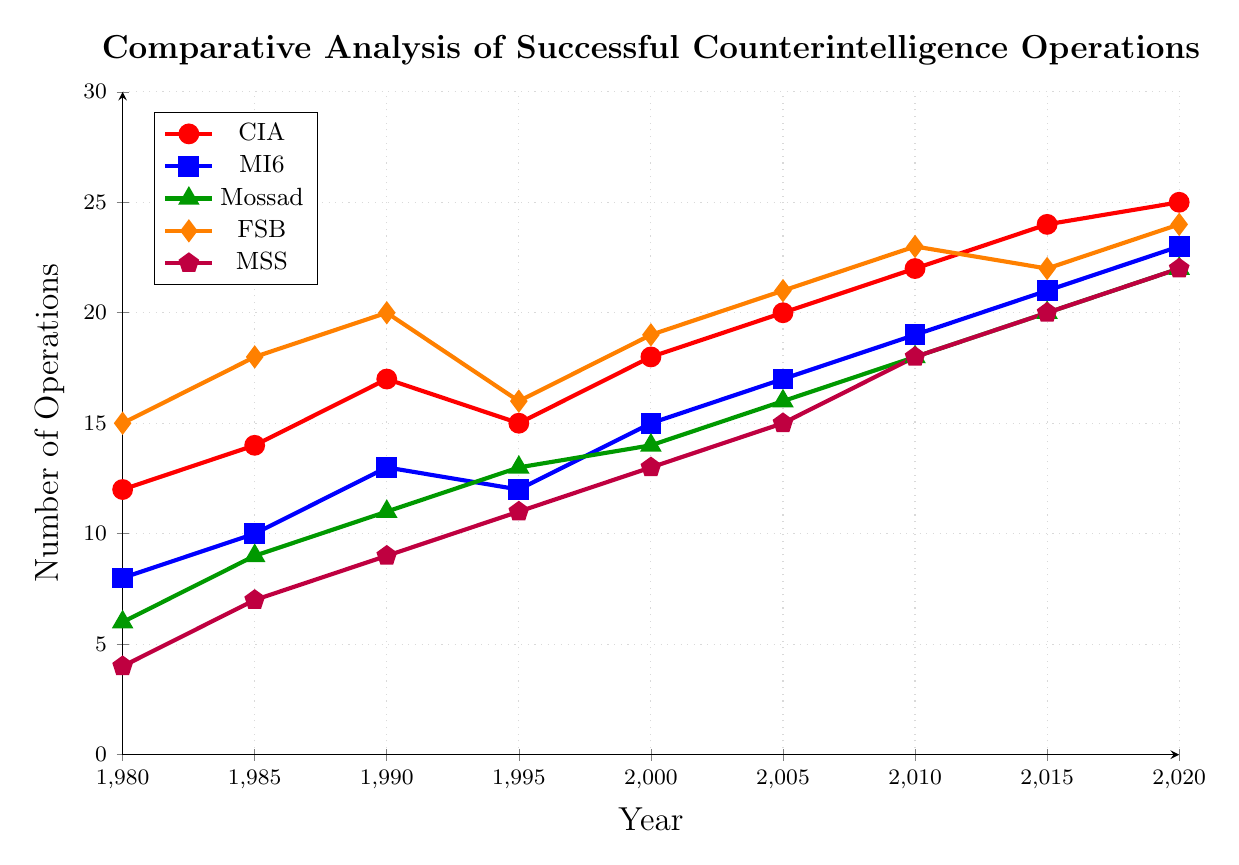Which agency had the most successful counterintelligence operations in 2020? The CIA is represented by the red line and shows the highest value in 2020 among all agencies, reaching 25 operations.
Answer: CIA How many more successful operations did the CIA have than Mossad in 2005? From the figure, the CIA had 20 operations in 2005 while Mossad had 16. Subtracting Mossad's operations from the CIA's gives 20 - 16.
Answer: 4 Which agency had a decrease in successful counterintelligence operations between 1990 and 1995? Observing the plot, the FSB (orange line) decreased from 20 operations in 1990 to 16 in 1995.
Answer: FSB What is the average number of successful operations for MI6 from 1990 to 2000? MI6's operations were 13 in 1990, 12 in 1995, and 15 in 2000. Adding these values gives 13 + 12 + 15 = 40, and the average is 40 / 3.
Answer: 13.33 Between 1980 and 2020, which agency had the highest increase in successful operations, and what was the increase? Comparing the values from 1980 to 2020 for each agency: CIA increased from 12 to 25 (13), MI6 from 8 to 23 (15), Mossad from 6 to 22 (16), FSB from 15 to 24 (9), and MSS from 4 to 22 (18). MSS had the highest increase of 18.
Answer: MSS, 18 In which year did MI6 have exactly 17 successful operations? Following the blue line for MI6, they had 17 operations in 2005.
Answer: 2005 Which agency had 20 successful operations in 2015, and what was its emblem in the figure? The green line for Mossad intersects the 20 operations mark in 2015, represented by a triangle.
Answer: Mossad, triangle How many agencies had more than 20 successful operations in 2020? Checking the values for 2020, the CIA (25), MI6 (23), Mossad (22), FSB (24), and MSS (22) all had more than 20 operations. This involves 5 agencies.
Answer: 5 What is the total number of successful operations by CIA and MSS in 1995? In 1995, CIA had 15 operations, and MSS had 11. Summing these gives 15 + 11 = 26.
Answer: 26 